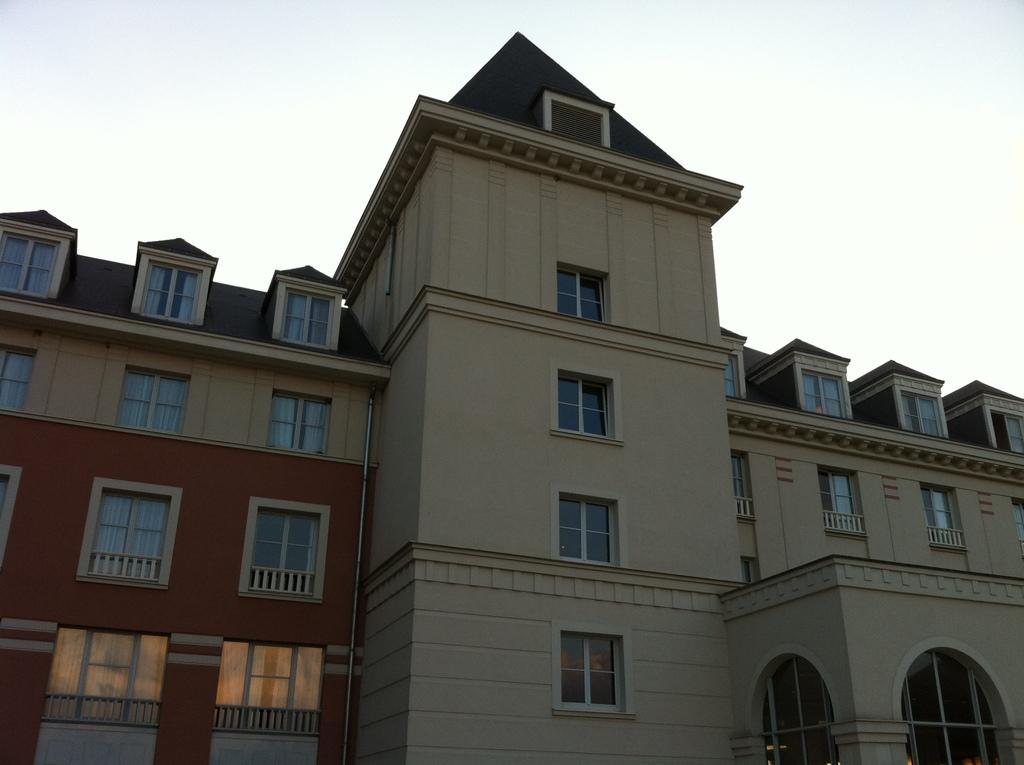What structure is present in the image? There is a building in the image. What feature of the building is mentioned in the facts? The building has many windows. What part of the natural environment is visible in the image? The sky is visible in the image. Can you tell me how the building rolls on the ground in the image? The building does not roll on the ground in the image; it is stationary. Is there any quicksand present in the image? There is no quicksand present in the image. 